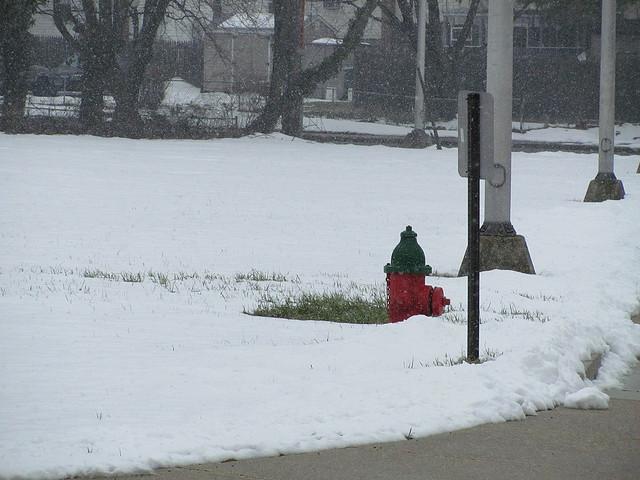Is the snow melting?
Write a very short answer. Yes. Is the snow covering all the grass?
Answer briefly. No. What type of weather day would this be?
Write a very short answer. Winter. 